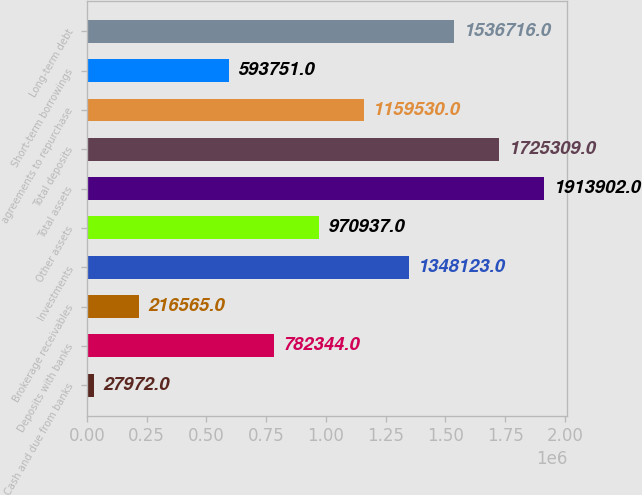Convert chart. <chart><loc_0><loc_0><loc_500><loc_500><bar_chart><fcel>Cash and due from banks<fcel>Deposits with banks<fcel>Brokerage receivables<fcel>Investments<fcel>Other assets<fcel>Total assets<fcel>Total deposits<fcel>agreements to repurchase<fcel>Short-term borrowings<fcel>Long-term debt<nl><fcel>27972<fcel>782344<fcel>216565<fcel>1.34812e+06<fcel>970937<fcel>1.9139e+06<fcel>1.72531e+06<fcel>1.15953e+06<fcel>593751<fcel>1.53672e+06<nl></chart> 